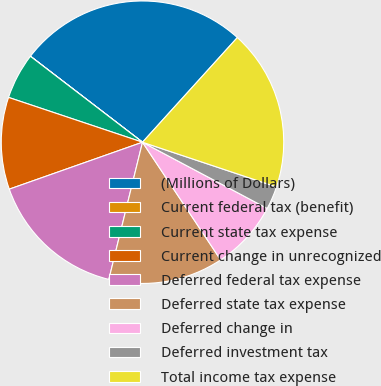<chart> <loc_0><loc_0><loc_500><loc_500><pie_chart><fcel>(Millions of Dollars)<fcel>Current federal tax (benefit)<fcel>Current state tax expense<fcel>Current change in unrecognized<fcel>Deferred federal tax expense<fcel>Deferred state tax expense<fcel>Deferred change in<fcel>Deferred investment tax<fcel>Total income tax expense<nl><fcel>26.3%<fcel>0.01%<fcel>5.27%<fcel>10.53%<fcel>15.78%<fcel>13.16%<fcel>7.9%<fcel>2.64%<fcel>18.41%<nl></chart> 